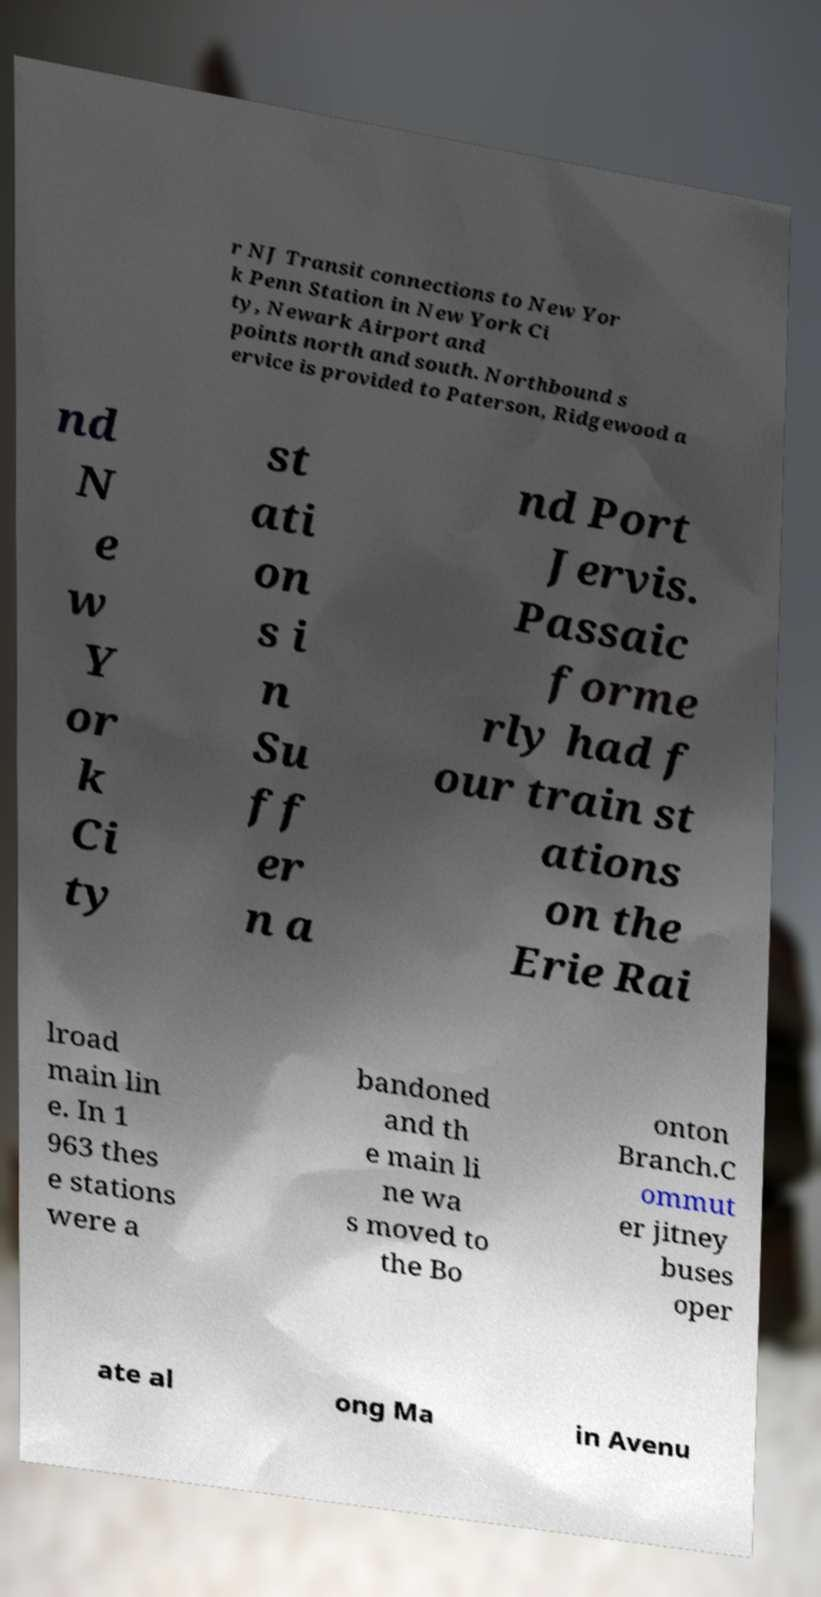Could you assist in decoding the text presented in this image and type it out clearly? r NJ Transit connections to New Yor k Penn Station in New York Ci ty, Newark Airport and points north and south. Northbound s ervice is provided to Paterson, Ridgewood a nd N e w Y or k Ci ty st ati on s i n Su ff er n a nd Port Jervis. Passaic forme rly had f our train st ations on the Erie Rai lroad main lin e. In 1 963 thes e stations were a bandoned and th e main li ne wa s moved to the Bo onton Branch.C ommut er jitney buses oper ate al ong Ma in Avenu 